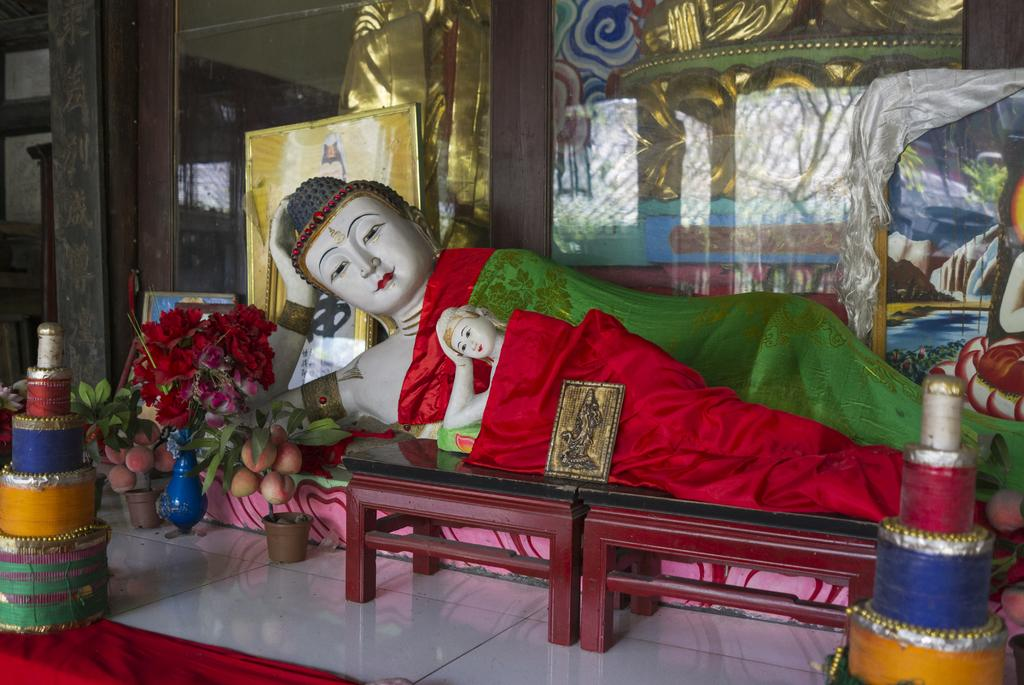What is the main subject in the image? There is a statue in the image. How is the statue positioned in the image? The statue is laying on a table. What can be seen on both sides of the image? There are flower pots on the left side and the right side of the image. What is visible in the background of the image? There is a glass door in the background of the image. What type of pencil is being used to draw on the statue in the image? There is no pencil or drawing activity present in the image; the statue is laying on a table. 